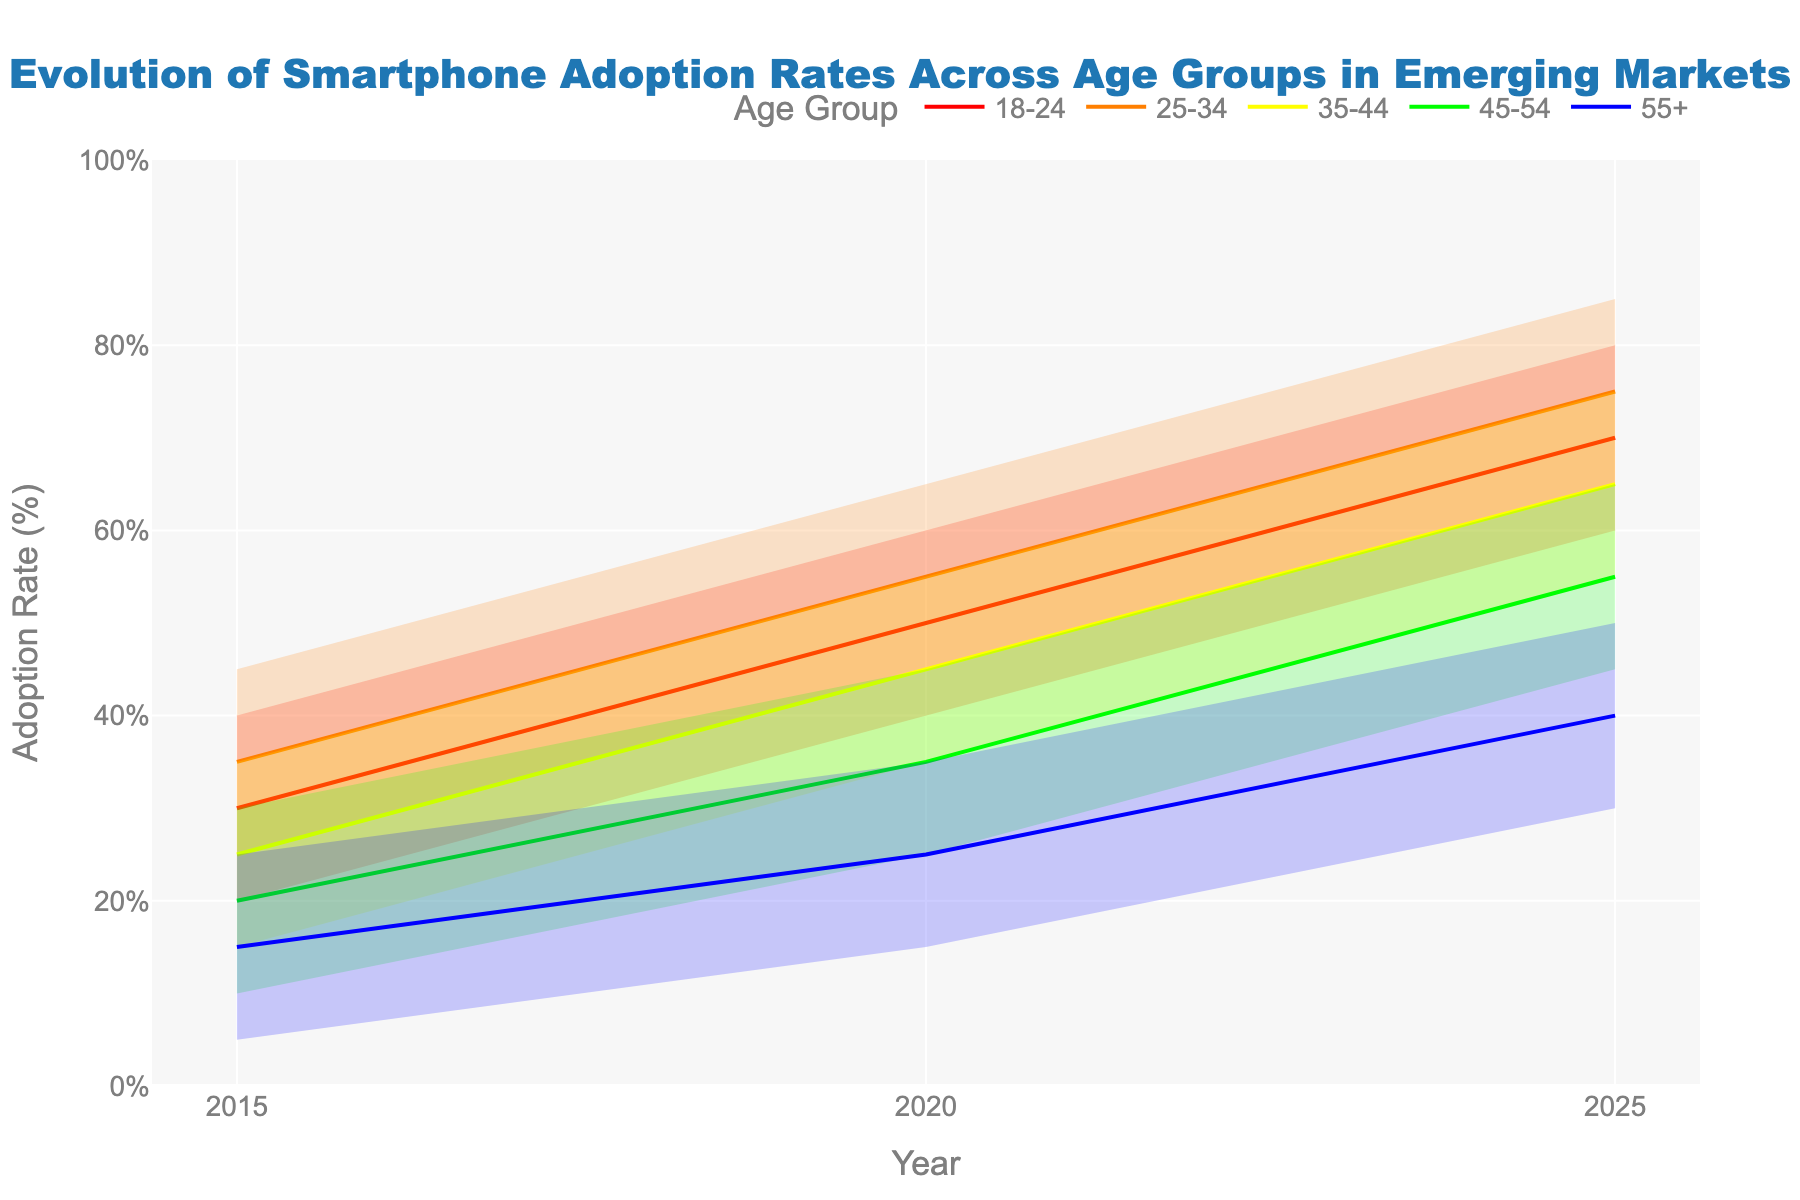What is the highest adoption rate for the 18-24 age group in 2025? Based on the figure, the highest adoption rate for the 18-24 age group is represented by the highest point of the shaded color band for that age group in the year 2025. It is 80%.
Answer: 80% What is the general trend of adoption rates for the 55+ age group from 2015 to 2025? Observing the line representing the 55+ age group from 2015 to 2025, you can see an upward trend indicating a steady increase in adoption rates. The mid values increase from 15% in 2015 to 40% in 2025.
Answer: Upward trend How do the adoption rates of the 25-34 age group differ between 2020 and 2025? Compare the mid values for the 25-34 age group in 2020 and 2025. In 2020, the mid value is 55%, while in 2025, it is 75%. The adoption rate increased by 20%.
Answer: Increased by 20% Which age group shows the most significant increase in adoption rates between 2015 and 2025? By examining the gap between the mid values in 2015 and 2025 for all age groups, the 18-24 age group shows an increase from 30% to 70%, making it a 40% increase, which is the largest among all age groups.
Answer: 18-24 age group What is the adoption rate range for the 45-54 age group in 2015? For the 45-54 age group in 2015, the adoption rates range from the lowest value to the highest value within the color band for that year, which are 10% and 30% respectively.
Answer: 10% to 30% Which age group had the lowest adoption rate in 2020? Look at the mid values for each age group in the year 2020 and identify the smallest value. The 55+ age group had the lowest mid adoption rate of 25%.
Answer: 55+ age group Is there any age group whose adoption rate doubled from 2015 to 2025? Calculate the mid values in 2015 and 2025 for each age group and check if any group's rate doubled. The mid value for the 55+ age group increased from 15% in 2015 to 40% in 2025, which did not double. The closest is the 18-24 age group from 30% to 70%, but again didn't double exactly. No exact doubling is found.
Answer: No What is the average adoption rate for the 35-44 age group in 2020? Add the five values for the 35-44 age group in 2020 (35%, 40%, 45%, 50%, and 55%) and divide by 5. The sum is 225%, so the average rate is 225% / 5 = 45%.
Answer: 45% Which age group had the smallest variance in adoption rates in 2015? Calculate the range (High-Low) for each age group in 2015. The age group with the smallest range has the smallest variance. For the 55+ age group, the range is from 5% to 25%, resulting in a variance of 20%, which is the smallest.
Answer: 55+ age group 